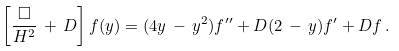Convert formula to latex. <formula><loc_0><loc_0><loc_500><loc_500>\left [ \frac { \square } { H ^ { 2 } } \, + \, D \right ] f ( y ) = ( 4 y \, - \, y ^ { 2 } ) f ^ { \prime \prime } + D ( 2 \, - \, y ) f ^ { \prime } + D f \, .</formula> 